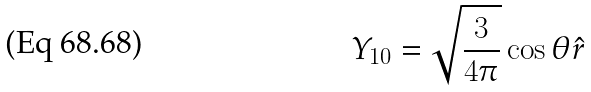<formula> <loc_0><loc_0><loc_500><loc_500>Y _ { 1 0 } = \sqrt { \frac { 3 } { 4 \pi } } \cos \theta \hat { r }</formula> 